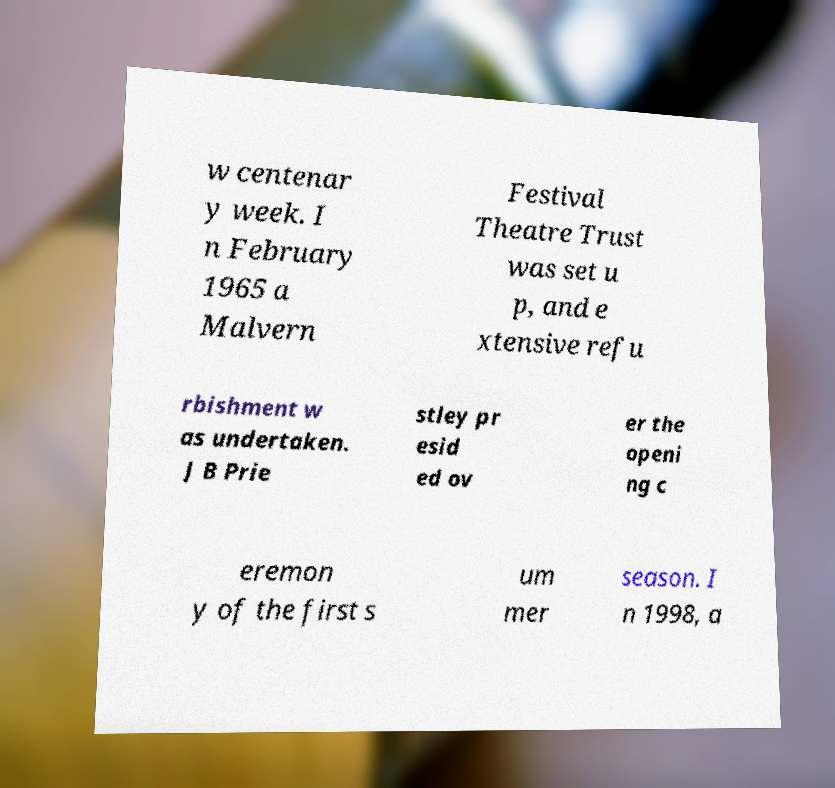What messages or text are displayed in this image? I need them in a readable, typed format. w centenar y week. I n February 1965 a Malvern Festival Theatre Trust was set u p, and e xtensive refu rbishment w as undertaken. J B Prie stley pr esid ed ov er the openi ng c eremon y of the first s um mer season. I n 1998, a 